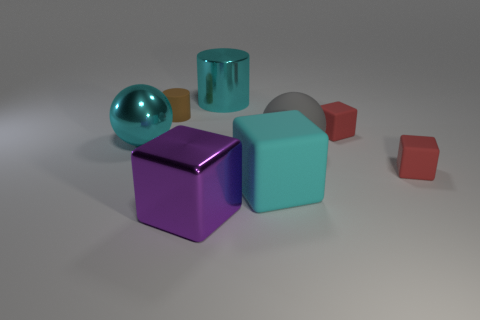What number of objects are either big purple shiny cubes or cyan shiny cylinders?
Provide a short and direct response. 2. The gray sphere to the right of the cyan cylinder behind the purple metal block is made of what material?
Your response must be concise. Rubber. Is there a large matte thing of the same color as the big metal cylinder?
Offer a very short reply. Yes. What color is the rubber sphere that is the same size as the purple object?
Your response must be concise. Gray. What material is the big cyan object to the left of the large object in front of the large block behind the metal cube made of?
Ensure brevity in your answer.  Metal. Is the color of the big shiny cylinder the same as the big cube that is on the right side of the large cyan cylinder?
Ensure brevity in your answer.  Yes. What number of things are either cubes that are behind the cyan rubber block or blocks behind the big purple shiny block?
Make the answer very short. 3. There is a large metallic thing that is on the left side of the large cube that is in front of the cyan matte object; what is its shape?
Offer a very short reply. Sphere. Is there a cyan block that has the same material as the tiny brown cylinder?
Keep it short and to the point. Yes. The other large thing that is the same shape as the purple shiny object is what color?
Offer a very short reply. Cyan. 